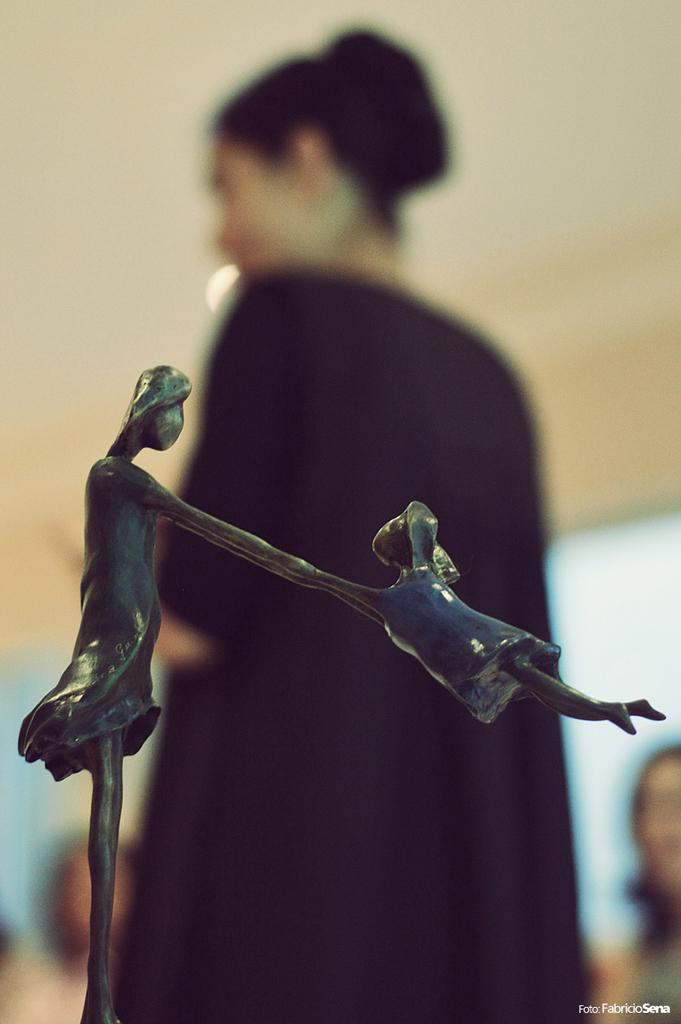Describe this image in one or two sentences. In this image we can see a metal structure, behind the metal structure there is a woman standing. 